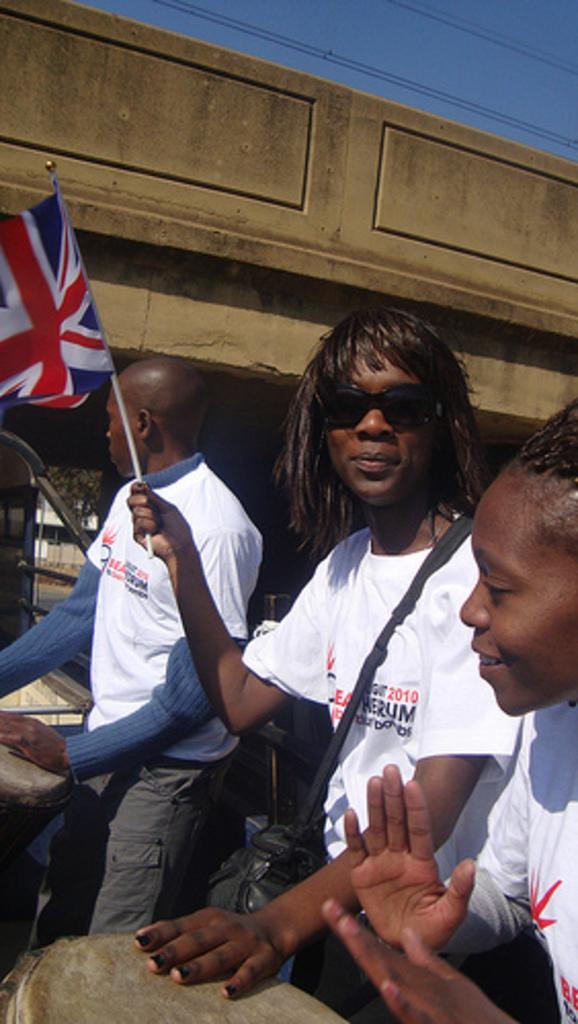How many people are in the image? There are three persons in the image. What is one of the persons doing in the image? One of the persons is catching a flag. What type of potato is being sold in the shop in the image? There is no shop or potato present in the image. What place is depicted in the image? The image does not depict a specific place; it only shows three persons and one of them catching a flag. 